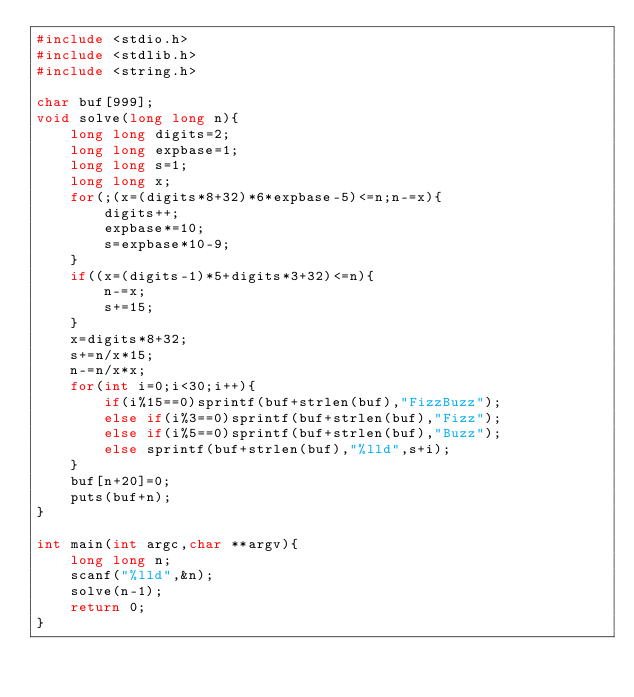Convert code to text. <code><loc_0><loc_0><loc_500><loc_500><_C_>#include <stdio.h>
#include <stdlib.h>
#include <string.h>

char buf[999];
void solve(long long n){
	long long digits=2;
	long long expbase=1;
	long long s=1;
	long long x;
	for(;(x=(digits*8+32)*6*expbase-5)<=n;n-=x){
		digits++;
		expbase*=10;
		s=expbase*10-9;
	}
	if((x=(digits-1)*5+digits*3+32)<=n){
		n-=x;
		s+=15;
	}
	x=digits*8+32;
	s+=n/x*15;
	n-=n/x*x;
	for(int i=0;i<30;i++){
		if(i%15==0)sprintf(buf+strlen(buf),"FizzBuzz");
		else if(i%3==0)sprintf(buf+strlen(buf),"Fizz");
		else if(i%5==0)sprintf(buf+strlen(buf),"Buzz");
		else sprintf(buf+strlen(buf),"%lld",s+i);
	}
	buf[n+20]=0;
	puts(buf+n);
}
 
int main(int argc,char **argv){
	long long n;
	scanf("%lld",&n);
	solve(n-1);
	return 0;
}</code> 